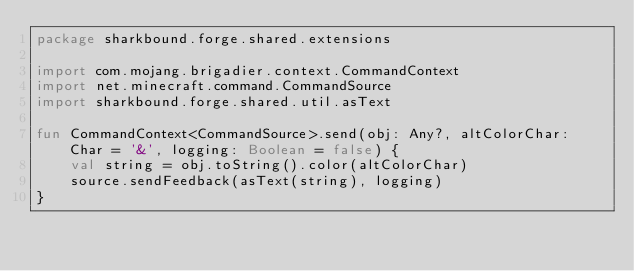Convert code to text. <code><loc_0><loc_0><loc_500><loc_500><_Kotlin_>package sharkbound.forge.shared.extensions

import com.mojang.brigadier.context.CommandContext
import net.minecraft.command.CommandSource
import sharkbound.forge.shared.util.asText

fun CommandContext<CommandSource>.send(obj: Any?, altColorChar: Char = '&', logging: Boolean = false) {
    val string = obj.toString().color(altColorChar)
    source.sendFeedback(asText(string), logging)
}</code> 